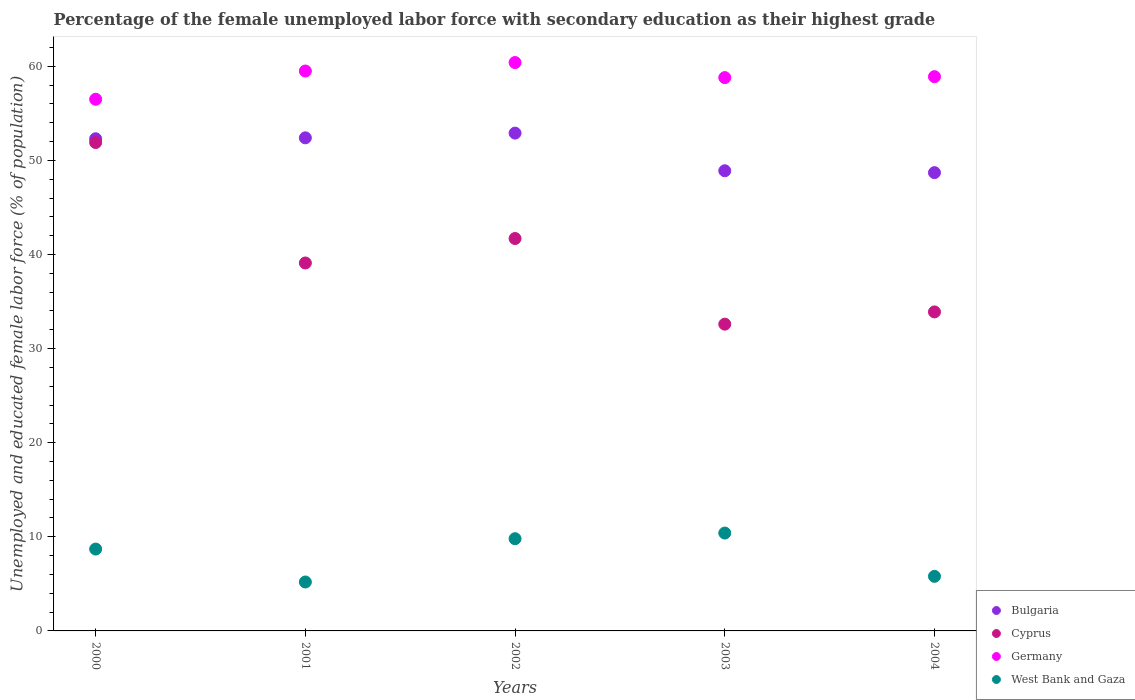How many different coloured dotlines are there?
Provide a short and direct response. 4. Is the number of dotlines equal to the number of legend labels?
Offer a very short reply. Yes. What is the percentage of the unemployed female labor force with secondary education in West Bank and Gaza in 2001?
Your answer should be very brief. 5.2. Across all years, what is the maximum percentage of the unemployed female labor force with secondary education in West Bank and Gaza?
Keep it short and to the point. 10.4. Across all years, what is the minimum percentage of the unemployed female labor force with secondary education in Germany?
Provide a short and direct response. 56.5. In which year was the percentage of the unemployed female labor force with secondary education in Cyprus maximum?
Ensure brevity in your answer.  2000. In which year was the percentage of the unemployed female labor force with secondary education in West Bank and Gaza minimum?
Ensure brevity in your answer.  2001. What is the total percentage of the unemployed female labor force with secondary education in West Bank and Gaza in the graph?
Your answer should be compact. 39.9. What is the difference between the percentage of the unemployed female labor force with secondary education in Bulgaria in 2000 and that in 2004?
Keep it short and to the point. 3.6. What is the difference between the percentage of the unemployed female labor force with secondary education in Bulgaria in 2004 and the percentage of the unemployed female labor force with secondary education in Cyprus in 2001?
Ensure brevity in your answer.  9.6. What is the average percentage of the unemployed female labor force with secondary education in Bulgaria per year?
Your answer should be compact. 51.04. In the year 2002, what is the difference between the percentage of the unemployed female labor force with secondary education in West Bank and Gaza and percentage of the unemployed female labor force with secondary education in Cyprus?
Your answer should be very brief. -31.9. What is the ratio of the percentage of the unemployed female labor force with secondary education in West Bank and Gaza in 2001 to that in 2002?
Offer a very short reply. 0.53. What is the difference between the highest and the lowest percentage of the unemployed female labor force with secondary education in Germany?
Your response must be concise. 3.9. In how many years, is the percentage of the unemployed female labor force with secondary education in Germany greater than the average percentage of the unemployed female labor force with secondary education in Germany taken over all years?
Give a very brief answer. 3. Is the sum of the percentage of the unemployed female labor force with secondary education in West Bank and Gaza in 2002 and 2004 greater than the maximum percentage of the unemployed female labor force with secondary education in Cyprus across all years?
Your response must be concise. No. Is it the case that in every year, the sum of the percentage of the unemployed female labor force with secondary education in Germany and percentage of the unemployed female labor force with secondary education in Cyprus  is greater than the sum of percentage of the unemployed female labor force with secondary education in West Bank and Gaza and percentage of the unemployed female labor force with secondary education in Bulgaria?
Provide a short and direct response. Yes. Does the percentage of the unemployed female labor force with secondary education in Bulgaria monotonically increase over the years?
Give a very brief answer. No. What is the difference between two consecutive major ticks on the Y-axis?
Ensure brevity in your answer.  10. Does the graph contain any zero values?
Give a very brief answer. No. Does the graph contain grids?
Your answer should be very brief. No. How are the legend labels stacked?
Offer a very short reply. Vertical. What is the title of the graph?
Your answer should be compact. Percentage of the female unemployed labor force with secondary education as their highest grade. Does "Kenya" appear as one of the legend labels in the graph?
Provide a short and direct response. No. What is the label or title of the Y-axis?
Make the answer very short. Unemployed and educated female labor force (% of population). What is the Unemployed and educated female labor force (% of population) of Bulgaria in 2000?
Ensure brevity in your answer.  52.3. What is the Unemployed and educated female labor force (% of population) in Cyprus in 2000?
Give a very brief answer. 51.9. What is the Unemployed and educated female labor force (% of population) of Germany in 2000?
Give a very brief answer. 56.5. What is the Unemployed and educated female labor force (% of population) of West Bank and Gaza in 2000?
Ensure brevity in your answer.  8.7. What is the Unemployed and educated female labor force (% of population) of Bulgaria in 2001?
Make the answer very short. 52.4. What is the Unemployed and educated female labor force (% of population) in Cyprus in 2001?
Your answer should be compact. 39.1. What is the Unemployed and educated female labor force (% of population) in Germany in 2001?
Make the answer very short. 59.5. What is the Unemployed and educated female labor force (% of population) in West Bank and Gaza in 2001?
Provide a short and direct response. 5.2. What is the Unemployed and educated female labor force (% of population) of Bulgaria in 2002?
Give a very brief answer. 52.9. What is the Unemployed and educated female labor force (% of population) of Cyprus in 2002?
Provide a succinct answer. 41.7. What is the Unemployed and educated female labor force (% of population) in Germany in 2002?
Offer a very short reply. 60.4. What is the Unemployed and educated female labor force (% of population) in West Bank and Gaza in 2002?
Your answer should be very brief. 9.8. What is the Unemployed and educated female labor force (% of population) in Bulgaria in 2003?
Make the answer very short. 48.9. What is the Unemployed and educated female labor force (% of population) of Cyprus in 2003?
Your answer should be very brief. 32.6. What is the Unemployed and educated female labor force (% of population) of Germany in 2003?
Offer a terse response. 58.8. What is the Unemployed and educated female labor force (% of population) of West Bank and Gaza in 2003?
Provide a succinct answer. 10.4. What is the Unemployed and educated female labor force (% of population) in Bulgaria in 2004?
Your answer should be compact. 48.7. What is the Unemployed and educated female labor force (% of population) in Cyprus in 2004?
Make the answer very short. 33.9. What is the Unemployed and educated female labor force (% of population) of Germany in 2004?
Your answer should be compact. 58.9. What is the Unemployed and educated female labor force (% of population) of West Bank and Gaza in 2004?
Offer a terse response. 5.8. Across all years, what is the maximum Unemployed and educated female labor force (% of population) in Bulgaria?
Keep it short and to the point. 52.9. Across all years, what is the maximum Unemployed and educated female labor force (% of population) of Cyprus?
Your answer should be compact. 51.9. Across all years, what is the maximum Unemployed and educated female labor force (% of population) in Germany?
Your answer should be compact. 60.4. Across all years, what is the maximum Unemployed and educated female labor force (% of population) in West Bank and Gaza?
Give a very brief answer. 10.4. Across all years, what is the minimum Unemployed and educated female labor force (% of population) of Bulgaria?
Ensure brevity in your answer.  48.7. Across all years, what is the minimum Unemployed and educated female labor force (% of population) of Cyprus?
Your answer should be very brief. 32.6. Across all years, what is the minimum Unemployed and educated female labor force (% of population) of Germany?
Your answer should be very brief. 56.5. Across all years, what is the minimum Unemployed and educated female labor force (% of population) in West Bank and Gaza?
Give a very brief answer. 5.2. What is the total Unemployed and educated female labor force (% of population) of Bulgaria in the graph?
Your answer should be very brief. 255.2. What is the total Unemployed and educated female labor force (% of population) in Cyprus in the graph?
Provide a short and direct response. 199.2. What is the total Unemployed and educated female labor force (% of population) of Germany in the graph?
Your answer should be compact. 294.1. What is the total Unemployed and educated female labor force (% of population) in West Bank and Gaza in the graph?
Offer a very short reply. 39.9. What is the difference between the Unemployed and educated female labor force (% of population) of Bulgaria in 2000 and that in 2001?
Provide a short and direct response. -0.1. What is the difference between the Unemployed and educated female labor force (% of population) in West Bank and Gaza in 2000 and that in 2001?
Offer a terse response. 3.5. What is the difference between the Unemployed and educated female labor force (% of population) of Bulgaria in 2000 and that in 2002?
Your response must be concise. -0.6. What is the difference between the Unemployed and educated female labor force (% of population) of Cyprus in 2000 and that in 2002?
Offer a very short reply. 10.2. What is the difference between the Unemployed and educated female labor force (% of population) in West Bank and Gaza in 2000 and that in 2002?
Offer a terse response. -1.1. What is the difference between the Unemployed and educated female labor force (% of population) in Bulgaria in 2000 and that in 2003?
Your answer should be very brief. 3.4. What is the difference between the Unemployed and educated female labor force (% of population) in Cyprus in 2000 and that in 2003?
Your answer should be compact. 19.3. What is the difference between the Unemployed and educated female labor force (% of population) of Germany in 2000 and that in 2003?
Make the answer very short. -2.3. What is the difference between the Unemployed and educated female labor force (% of population) in West Bank and Gaza in 2000 and that in 2003?
Offer a very short reply. -1.7. What is the difference between the Unemployed and educated female labor force (% of population) in Bulgaria in 2000 and that in 2004?
Give a very brief answer. 3.6. What is the difference between the Unemployed and educated female labor force (% of population) of Germany in 2000 and that in 2004?
Your answer should be very brief. -2.4. What is the difference between the Unemployed and educated female labor force (% of population) in West Bank and Gaza in 2000 and that in 2004?
Your answer should be very brief. 2.9. What is the difference between the Unemployed and educated female labor force (% of population) in Bulgaria in 2001 and that in 2002?
Your answer should be very brief. -0.5. What is the difference between the Unemployed and educated female labor force (% of population) in Germany in 2001 and that in 2002?
Your answer should be very brief. -0.9. What is the difference between the Unemployed and educated female labor force (% of population) of Bulgaria in 2001 and that in 2003?
Offer a very short reply. 3.5. What is the difference between the Unemployed and educated female labor force (% of population) of Cyprus in 2001 and that in 2003?
Ensure brevity in your answer.  6.5. What is the difference between the Unemployed and educated female labor force (% of population) of West Bank and Gaza in 2001 and that in 2003?
Keep it short and to the point. -5.2. What is the difference between the Unemployed and educated female labor force (% of population) of Cyprus in 2001 and that in 2004?
Offer a very short reply. 5.2. What is the difference between the Unemployed and educated female labor force (% of population) in Germany in 2001 and that in 2004?
Your answer should be compact. 0.6. What is the difference between the Unemployed and educated female labor force (% of population) in Bulgaria in 2002 and that in 2003?
Keep it short and to the point. 4. What is the difference between the Unemployed and educated female labor force (% of population) in Germany in 2002 and that in 2003?
Provide a short and direct response. 1.6. What is the difference between the Unemployed and educated female labor force (% of population) in Germany in 2003 and that in 2004?
Provide a short and direct response. -0.1. What is the difference between the Unemployed and educated female labor force (% of population) in Bulgaria in 2000 and the Unemployed and educated female labor force (% of population) in West Bank and Gaza in 2001?
Offer a terse response. 47.1. What is the difference between the Unemployed and educated female labor force (% of population) of Cyprus in 2000 and the Unemployed and educated female labor force (% of population) of West Bank and Gaza in 2001?
Offer a very short reply. 46.7. What is the difference between the Unemployed and educated female labor force (% of population) in Germany in 2000 and the Unemployed and educated female labor force (% of population) in West Bank and Gaza in 2001?
Give a very brief answer. 51.3. What is the difference between the Unemployed and educated female labor force (% of population) of Bulgaria in 2000 and the Unemployed and educated female labor force (% of population) of Germany in 2002?
Your response must be concise. -8.1. What is the difference between the Unemployed and educated female labor force (% of population) in Bulgaria in 2000 and the Unemployed and educated female labor force (% of population) in West Bank and Gaza in 2002?
Your answer should be compact. 42.5. What is the difference between the Unemployed and educated female labor force (% of population) of Cyprus in 2000 and the Unemployed and educated female labor force (% of population) of Germany in 2002?
Your answer should be very brief. -8.5. What is the difference between the Unemployed and educated female labor force (% of population) in Cyprus in 2000 and the Unemployed and educated female labor force (% of population) in West Bank and Gaza in 2002?
Provide a succinct answer. 42.1. What is the difference between the Unemployed and educated female labor force (% of population) in Germany in 2000 and the Unemployed and educated female labor force (% of population) in West Bank and Gaza in 2002?
Your answer should be compact. 46.7. What is the difference between the Unemployed and educated female labor force (% of population) in Bulgaria in 2000 and the Unemployed and educated female labor force (% of population) in West Bank and Gaza in 2003?
Offer a terse response. 41.9. What is the difference between the Unemployed and educated female labor force (% of population) in Cyprus in 2000 and the Unemployed and educated female labor force (% of population) in Germany in 2003?
Your response must be concise. -6.9. What is the difference between the Unemployed and educated female labor force (% of population) in Cyprus in 2000 and the Unemployed and educated female labor force (% of population) in West Bank and Gaza in 2003?
Ensure brevity in your answer.  41.5. What is the difference between the Unemployed and educated female labor force (% of population) of Germany in 2000 and the Unemployed and educated female labor force (% of population) of West Bank and Gaza in 2003?
Provide a succinct answer. 46.1. What is the difference between the Unemployed and educated female labor force (% of population) in Bulgaria in 2000 and the Unemployed and educated female labor force (% of population) in Germany in 2004?
Offer a very short reply. -6.6. What is the difference between the Unemployed and educated female labor force (% of population) in Bulgaria in 2000 and the Unemployed and educated female labor force (% of population) in West Bank and Gaza in 2004?
Make the answer very short. 46.5. What is the difference between the Unemployed and educated female labor force (% of population) in Cyprus in 2000 and the Unemployed and educated female labor force (% of population) in West Bank and Gaza in 2004?
Provide a succinct answer. 46.1. What is the difference between the Unemployed and educated female labor force (% of population) of Germany in 2000 and the Unemployed and educated female labor force (% of population) of West Bank and Gaza in 2004?
Your response must be concise. 50.7. What is the difference between the Unemployed and educated female labor force (% of population) of Bulgaria in 2001 and the Unemployed and educated female labor force (% of population) of Cyprus in 2002?
Ensure brevity in your answer.  10.7. What is the difference between the Unemployed and educated female labor force (% of population) of Bulgaria in 2001 and the Unemployed and educated female labor force (% of population) of West Bank and Gaza in 2002?
Offer a very short reply. 42.6. What is the difference between the Unemployed and educated female labor force (% of population) in Cyprus in 2001 and the Unemployed and educated female labor force (% of population) in Germany in 2002?
Offer a very short reply. -21.3. What is the difference between the Unemployed and educated female labor force (% of population) of Cyprus in 2001 and the Unemployed and educated female labor force (% of population) of West Bank and Gaza in 2002?
Ensure brevity in your answer.  29.3. What is the difference between the Unemployed and educated female labor force (% of population) in Germany in 2001 and the Unemployed and educated female labor force (% of population) in West Bank and Gaza in 2002?
Keep it short and to the point. 49.7. What is the difference between the Unemployed and educated female labor force (% of population) of Bulgaria in 2001 and the Unemployed and educated female labor force (% of population) of Cyprus in 2003?
Provide a short and direct response. 19.8. What is the difference between the Unemployed and educated female labor force (% of population) of Bulgaria in 2001 and the Unemployed and educated female labor force (% of population) of West Bank and Gaza in 2003?
Ensure brevity in your answer.  42. What is the difference between the Unemployed and educated female labor force (% of population) of Cyprus in 2001 and the Unemployed and educated female labor force (% of population) of Germany in 2003?
Provide a succinct answer. -19.7. What is the difference between the Unemployed and educated female labor force (% of population) of Cyprus in 2001 and the Unemployed and educated female labor force (% of population) of West Bank and Gaza in 2003?
Make the answer very short. 28.7. What is the difference between the Unemployed and educated female labor force (% of population) in Germany in 2001 and the Unemployed and educated female labor force (% of population) in West Bank and Gaza in 2003?
Give a very brief answer. 49.1. What is the difference between the Unemployed and educated female labor force (% of population) of Bulgaria in 2001 and the Unemployed and educated female labor force (% of population) of Germany in 2004?
Offer a terse response. -6.5. What is the difference between the Unemployed and educated female labor force (% of population) of Bulgaria in 2001 and the Unemployed and educated female labor force (% of population) of West Bank and Gaza in 2004?
Offer a very short reply. 46.6. What is the difference between the Unemployed and educated female labor force (% of population) in Cyprus in 2001 and the Unemployed and educated female labor force (% of population) in Germany in 2004?
Provide a short and direct response. -19.8. What is the difference between the Unemployed and educated female labor force (% of population) of Cyprus in 2001 and the Unemployed and educated female labor force (% of population) of West Bank and Gaza in 2004?
Keep it short and to the point. 33.3. What is the difference between the Unemployed and educated female labor force (% of population) of Germany in 2001 and the Unemployed and educated female labor force (% of population) of West Bank and Gaza in 2004?
Your response must be concise. 53.7. What is the difference between the Unemployed and educated female labor force (% of population) of Bulgaria in 2002 and the Unemployed and educated female labor force (% of population) of Cyprus in 2003?
Give a very brief answer. 20.3. What is the difference between the Unemployed and educated female labor force (% of population) in Bulgaria in 2002 and the Unemployed and educated female labor force (% of population) in Germany in 2003?
Your response must be concise. -5.9. What is the difference between the Unemployed and educated female labor force (% of population) in Bulgaria in 2002 and the Unemployed and educated female labor force (% of population) in West Bank and Gaza in 2003?
Ensure brevity in your answer.  42.5. What is the difference between the Unemployed and educated female labor force (% of population) of Cyprus in 2002 and the Unemployed and educated female labor force (% of population) of Germany in 2003?
Your response must be concise. -17.1. What is the difference between the Unemployed and educated female labor force (% of population) in Cyprus in 2002 and the Unemployed and educated female labor force (% of population) in West Bank and Gaza in 2003?
Ensure brevity in your answer.  31.3. What is the difference between the Unemployed and educated female labor force (% of population) of Germany in 2002 and the Unemployed and educated female labor force (% of population) of West Bank and Gaza in 2003?
Offer a terse response. 50. What is the difference between the Unemployed and educated female labor force (% of population) in Bulgaria in 2002 and the Unemployed and educated female labor force (% of population) in West Bank and Gaza in 2004?
Keep it short and to the point. 47.1. What is the difference between the Unemployed and educated female labor force (% of population) in Cyprus in 2002 and the Unemployed and educated female labor force (% of population) in Germany in 2004?
Provide a short and direct response. -17.2. What is the difference between the Unemployed and educated female labor force (% of population) in Cyprus in 2002 and the Unemployed and educated female labor force (% of population) in West Bank and Gaza in 2004?
Your answer should be very brief. 35.9. What is the difference between the Unemployed and educated female labor force (% of population) in Germany in 2002 and the Unemployed and educated female labor force (% of population) in West Bank and Gaza in 2004?
Offer a very short reply. 54.6. What is the difference between the Unemployed and educated female labor force (% of population) in Bulgaria in 2003 and the Unemployed and educated female labor force (% of population) in West Bank and Gaza in 2004?
Your answer should be compact. 43.1. What is the difference between the Unemployed and educated female labor force (% of population) of Cyprus in 2003 and the Unemployed and educated female labor force (% of population) of Germany in 2004?
Give a very brief answer. -26.3. What is the difference between the Unemployed and educated female labor force (% of population) of Cyprus in 2003 and the Unemployed and educated female labor force (% of population) of West Bank and Gaza in 2004?
Your answer should be very brief. 26.8. What is the difference between the Unemployed and educated female labor force (% of population) of Germany in 2003 and the Unemployed and educated female labor force (% of population) of West Bank and Gaza in 2004?
Provide a short and direct response. 53. What is the average Unemployed and educated female labor force (% of population) of Bulgaria per year?
Make the answer very short. 51.04. What is the average Unemployed and educated female labor force (% of population) of Cyprus per year?
Provide a succinct answer. 39.84. What is the average Unemployed and educated female labor force (% of population) of Germany per year?
Your answer should be compact. 58.82. What is the average Unemployed and educated female labor force (% of population) in West Bank and Gaza per year?
Your answer should be very brief. 7.98. In the year 2000, what is the difference between the Unemployed and educated female labor force (% of population) in Bulgaria and Unemployed and educated female labor force (% of population) in West Bank and Gaza?
Provide a short and direct response. 43.6. In the year 2000, what is the difference between the Unemployed and educated female labor force (% of population) in Cyprus and Unemployed and educated female labor force (% of population) in West Bank and Gaza?
Provide a short and direct response. 43.2. In the year 2000, what is the difference between the Unemployed and educated female labor force (% of population) of Germany and Unemployed and educated female labor force (% of population) of West Bank and Gaza?
Give a very brief answer. 47.8. In the year 2001, what is the difference between the Unemployed and educated female labor force (% of population) of Bulgaria and Unemployed and educated female labor force (% of population) of West Bank and Gaza?
Keep it short and to the point. 47.2. In the year 2001, what is the difference between the Unemployed and educated female labor force (% of population) in Cyprus and Unemployed and educated female labor force (% of population) in Germany?
Provide a short and direct response. -20.4. In the year 2001, what is the difference between the Unemployed and educated female labor force (% of population) in Cyprus and Unemployed and educated female labor force (% of population) in West Bank and Gaza?
Your response must be concise. 33.9. In the year 2001, what is the difference between the Unemployed and educated female labor force (% of population) in Germany and Unemployed and educated female labor force (% of population) in West Bank and Gaza?
Make the answer very short. 54.3. In the year 2002, what is the difference between the Unemployed and educated female labor force (% of population) of Bulgaria and Unemployed and educated female labor force (% of population) of West Bank and Gaza?
Offer a terse response. 43.1. In the year 2002, what is the difference between the Unemployed and educated female labor force (% of population) in Cyprus and Unemployed and educated female labor force (% of population) in Germany?
Ensure brevity in your answer.  -18.7. In the year 2002, what is the difference between the Unemployed and educated female labor force (% of population) of Cyprus and Unemployed and educated female labor force (% of population) of West Bank and Gaza?
Keep it short and to the point. 31.9. In the year 2002, what is the difference between the Unemployed and educated female labor force (% of population) in Germany and Unemployed and educated female labor force (% of population) in West Bank and Gaza?
Your answer should be very brief. 50.6. In the year 2003, what is the difference between the Unemployed and educated female labor force (% of population) in Bulgaria and Unemployed and educated female labor force (% of population) in West Bank and Gaza?
Give a very brief answer. 38.5. In the year 2003, what is the difference between the Unemployed and educated female labor force (% of population) in Cyprus and Unemployed and educated female labor force (% of population) in Germany?
Make the answer very short. -26.2. In the year 2003, what is the difference between the Unemployed and educated female labor force (% of population) of Germany and Unemployed and educated female labor force (% of population) of West Bank and Gaza?
Provide a succinct answer. 48.4. In the year 2004, what is the difference between the Unemployed and educated female labor force (% of population) of Bulgaria and Unemployed and educated female labor force (% of population) of West Bank and Gaza?
Offer a very short reply. 42.9. In the year 2004, what is the difference between the Unemployed and educated female labor force (% of population) in Cyprus and Unemployed and educated female labor force (% of population) in West Bank and Gaza?
Keep it short and to the point. 28.1. In the year 2004, what is the difference between the Unemployed and educated female labor force (% of population) of Germany and Unemployed and educated female labor force (% of population) of West Bank and Gaza?
Your answer should be compact. 53.1. What is the ratio of the Unemployed and educated female labor force (% of population) of Bulgaria in 2000 to that in 2001?
Your answer should be very brief. 1. What is the ratio of the Unemployed and educated female labor force (% of population) in Cyprus in 2000 to that in 2001?
Offer a very short reply. 1.33. What is the ratio of the Unemployed and educated female labor force (% of population) of Germany in 2000 to that in 2001?
Provide a short and direct response. 0.95. What is the ratio of the Unemployed and educated female labor force (% of population) in West Bank and Gaza in 2000 to that in 2001?
Offer a very short reply. 1.67. What is the ratio of the Unemployed and educated female labor force (% of population) in Bulgaria in 2000 to that in 2002?
Keep it short and to the point. 0.99. What is the ratio of the Unemployed and educated female labor force (% of population) of Cyprus in 2000 to that in 2002?
Offer a terse response. 1.24. What is the ratio of the Unemployed and educated female labor force (% of population) in Germany in 2000 to that in 2002?
Ensure brevity in your answer.  0.94. What is the ratio of the Unemployed and educated female labor force (% of population) of West Bank and Gaza in 2000 to that in 2002?
Offer a terse response. 0.89. What is the ratio of the Unemployed and educated female labor force (% of population) of Bulgaria in 2000 to that in 2003?
Your response must be concise. 1.07. What is the ratio of the Unemployed and educated female labor force (% of population) of Cyprus in 2000 to that in 2003?
Ensure brevity in your answer.  1.59. What is the ratio of the Unemployed and educated female labor force (% of population) of Germany in 2000 to that in 2003?
Make the answer very short. 0.96. What is the ratio of the Unemployed and educated female labor force (% of population) of West Bank and Gaza in 2000 to that in 2003?
Your response must be concise. 0.84. What is the ratio of the Unemployed and educated female labor force (% of population) in Bulgaria in 2000 to that in 2004?
Offer a very short reply. 1.07. What is the ratio of the Unemployed and educated female labor force (% of population) in Cyprus in 2000 to that in 2004?
Ensure brevity in your answer.  1.53. What is the ratio of the Unemployed and educated female labor force (% of population) of Germany in 2000 to that in 2004?
Ensure brevity in your answer.  0.96. What is the ratio of the Unemployed and educated female labor force (% of population) of West Bank and Gaza in 2000 to that in 2004?
Keep it short and to the point. 1.5. What is the ratio of the Unemployed and educated female labor force (% of population) of Bulgaria in 2001 to that in 2002?
Make the answer very short. 0.99. What is the ratio of the Unemployed and educated female labor force (% of population) in Cyprus in 2001 to that in 2002?
Keep it short and to the point. 0.94. What is the ratio of the Unemployed and educated female labor force (% of population) in Germany in 2001 to that in 2002?
Your response must be concise. 0.99. What is the ratio of the Unemployed and educated female labor force (% of population) in West Bank and Gaza in 2001 to that in 2002?
Provide a short and direct response. 0.53. What is the ratio of the Unemployed and educated female labor force (% of population) of Bulgaria in 2001 to that in 2003?
Make the answer very short. 1.07. What is the ratio of the Unemployed and educated female labor force (% of population) in Cyprus in 2001 to that in 2003?
Keep it short and to the point. 1.2. What is the ratio of the Unemployed and educated female labor force (% of population) in Germany in 2001 to that in 2003?
Provide a short and direct response. 1.01. What is the ratio of the Unemployed and educated female labor force (% of population) in Bulgaria in 2001 to that in 2004?
Provide a succinct answer. 1.08. What is the ratio of the Unemployed and educated female labor force (% of population) in Cyprus in 2001 to that in 2004?
Your answer should be compact. 1.15. What is the ratio of the Unemployed and educated female labor force (% of population) in Germany in 2001 to that in 2004?
Give a very brief answer. 1.01. What is the ratio of the Unemployed and educated female labor force (% of population) in West Bank and Gaza in 2001 to that in 2004?
Offer a very short reply. 0.9. What is the ratio of the Unemployed and educated female labor force (% of population) of Bulgaria in 2002 to that in 2003?
Your answer should be very brief. 1.08. What is the ratio of the Unemployed and educated female labor force (% of population) in Cyprus in 2002 to that in 2003?
Provide a short and direct response. 1.28. What is the ratio of the Unemployed and educated female labor force (% of population) in Germany in 2002 to that in 2003?
Offer a very short reply. 1.03. What is the ratio of the Unemployed and educated female labor force (% of population) in West Bank and Gaza in 2002 to that in 2003?
Your answer should be very brief. 0.94. What is the ratio of the Unemployed and educated female labor force (% of population) in Bulgaria in 2002 to that in 2004?
Offer a terse response. 1.09. What is the ratio of the Unemployed and educated female labor force (% of population) of Cyprus in 2002 to that in 2004?
Offer a very short reply. 1.23. What is the ratio of the Unemployed and educated female labor force (% of population) in Germany in 2002 to that in 2004?
Your response must be concise. 1.03. What is the ratio of the Unemployed and educated female labor force (% of population) in West Bank and Gaza in 2002 to that in 2004?
Ensure brevity in your answer.  1.69. What is the ratio of the Unemployed and educated female labor force (% of population) in Cyprus in 2003 to that in 2004?
Your answer should be compact. 0.96. What is the ratio of the Unemployed and educated female labor force (% of population) of West Bank and Gaza in 2003 to that in 2004?
Offer a very short reply. 1.79. What is the difference between the highest and the second highest Unemployed and educated female labor force (% of population) of Bulgaria?
Your answer should be very brief. 0.5. What is the difference between the highest and the lowest Unemployed and educated female labor force (% of population) of Cyprus?
Your answer should be compact. 19.3. What is the difference between the highest and the lowest Unemployed and educated female labor force (% of population) of West Bank and Gaza?
Make the answer very short. 5.2. 